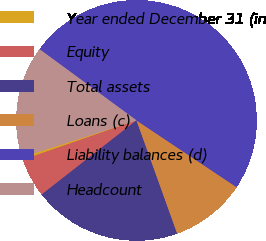Convert chart. <chart><loc_0><loc_0><loc_500><loc_500><pie_chart><fcel>Year ended December 31 (in<fcel>Equity<fcel>Total assets<fcel>Loans (c)<fcel>Liability balances (d)<fcel>Headcount<nl><fcel>0.35%<fcel>5.25%<fcel>19.93%<fcel>10.14%<fcel>49.29%<fcel>15.04%<nl></chart> 